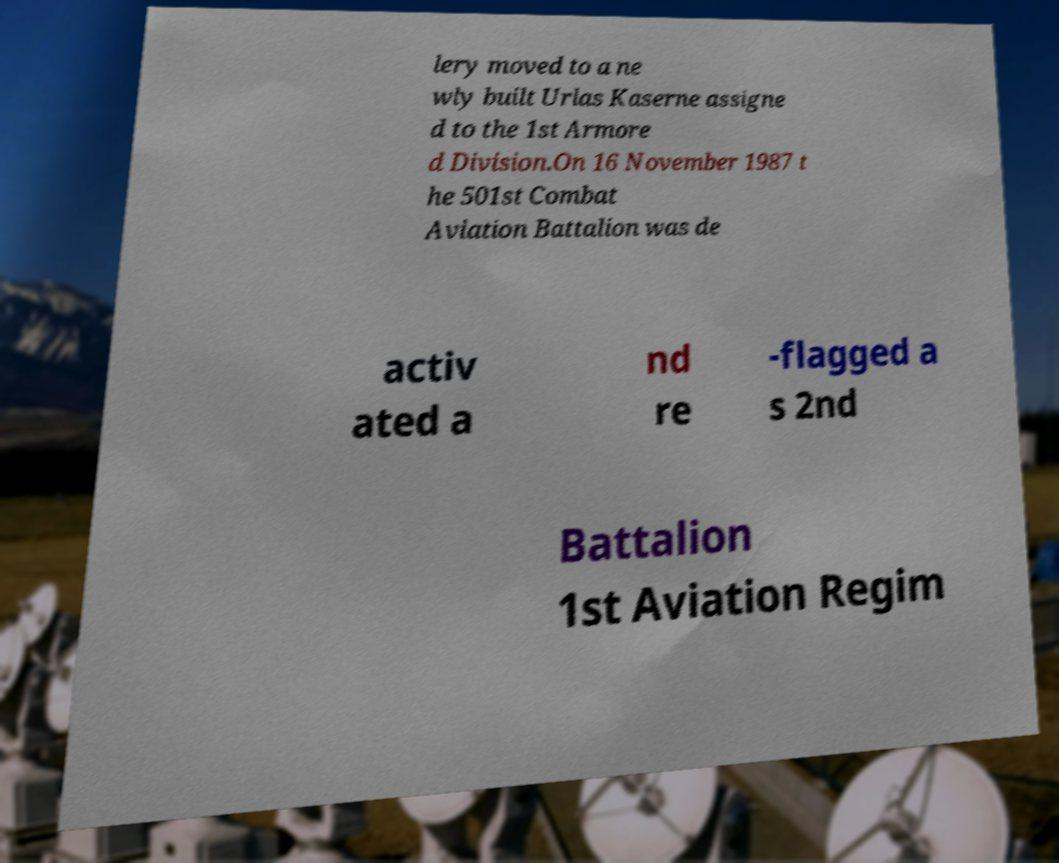I need the written content from this picture converted into text. Can you do that? lery moved to a ne wly built Urlas Kaserne assigne d to the 1st Armore d Division.On 16 November 1987 t he 501st Combat Aviation Battalion was de activ ated a nd re -flagged a s 2nd Battalion 1st Aviation Regim 